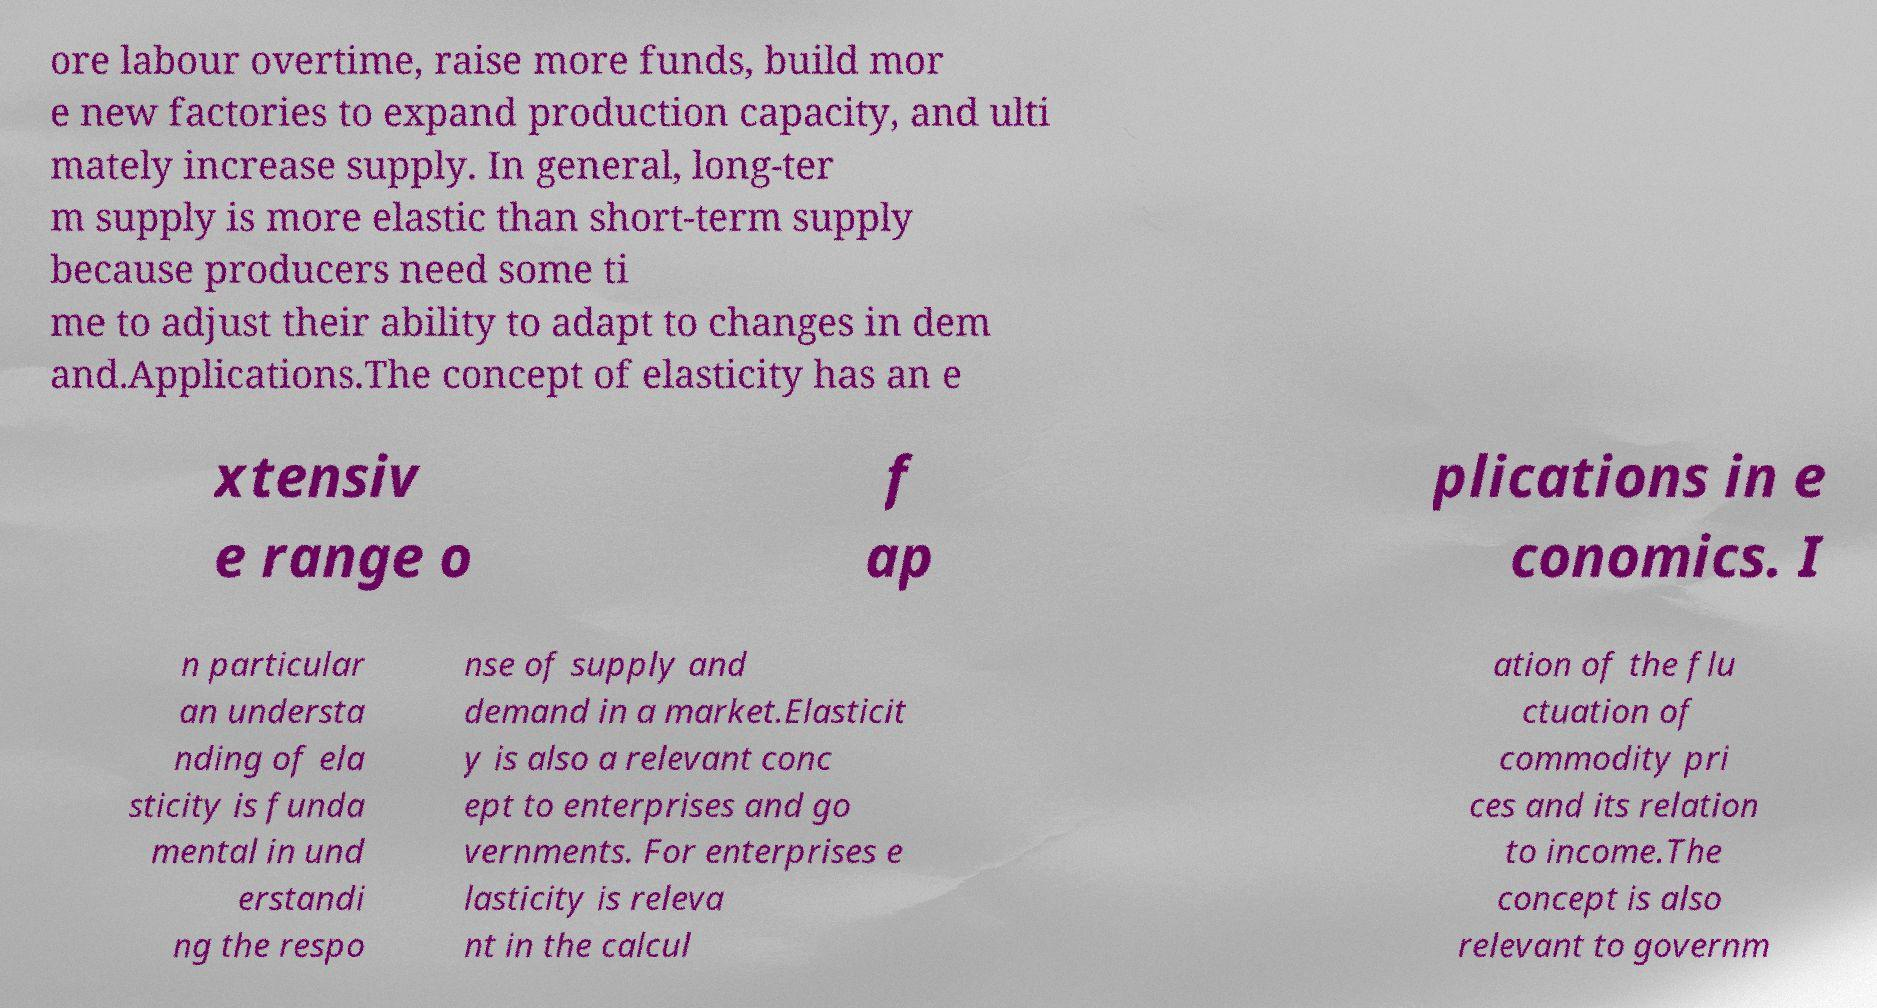There's text embedded in this image that I need extracted. Can you transcribe it verbatim? ore labour overtime, raise more funds, build mor e new factories to expand production capacity, and ulti mately increase supply. In general, long-ter m supply is more elastic than short-term supply because producers need some ti me to adjust their ability to adapt to changes in dem and.Applications.The concept of elasticity has an e xtensiv e range o f ap plications in e conomics. I n particular an understa nding of ela sticity is funda mental in und erstandi ng the respo nse of supply and demand in a market.Elasticit y is also a relevant conc ept to enterprises and go vernments. For enterprises e lasticity is releva nt in the calcul ation of the flu ctuation of commodity pri ces and its relation to income.The concept is also relevant to governm 